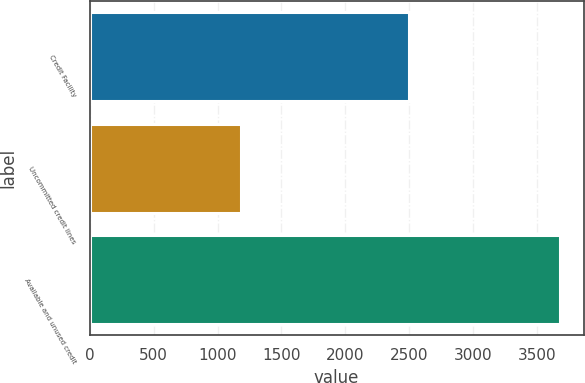Convert chart to OTSL. <chart><loc_0><loc_0><loc_500><loc_500><bar_chart><fcel>Credit Facility<fcel>Uncommitted credit lines<fcel>Available and unused credit<nl><fcel>2500<fcel>1181<fcel>3681<nl></chart> 